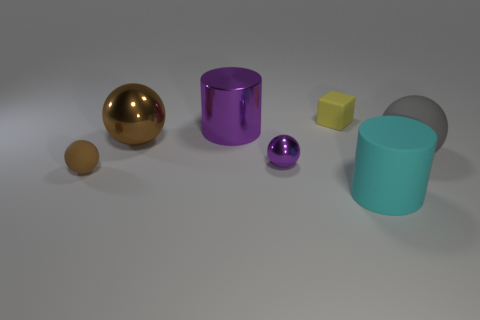Subtract all yellow balls. Subtract all red blocks. How many balls are left? 4 Add 2 small rubber things. How many objects exist? 9 Subtract all cylinders. How many objects are left? 5 Add 2 tiny shiny objects. How many tiny shiny objects exist? 3 Subtract 0 green blocks. How many objects are left? 7 Subtract all tiny yellow cubes. Subtract all large rubber spheres. How many objects are left? 5 Add 2 brown metallic spheres. How many brown metallic spheres are left? 3 